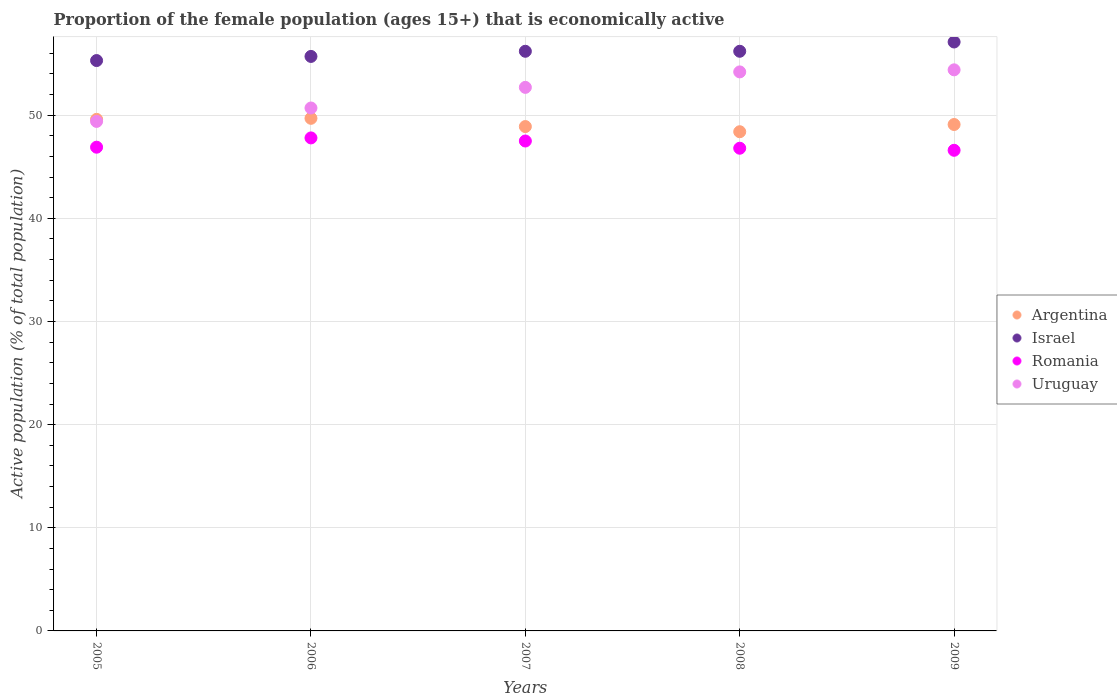Is the number of dotlines equal to the number of legend labels?
Offer a very short reply. Yes. What is the proportion of the female population that is economically active in Argentina in 2009?
Your answer should be compact. 49.1. Across all years, what is the maximum proportion of the female population that is economically active in Argentina?
Your answer should be very brief. 49.7. Across all years, what is the minimum proportion of the female population that is economically active in Romania?
Keep it short and to the point. 46.6. In which year was the proportion of the female population that is economically active in Romania maximum?
Your answer should be very brief. 2006. What is the total proportion of the female population that is economically active in Argentina in the graph?
Provide a short and direct response. 245.7. What is the difference between the proportion of the female population that is economically active in Uruguay in 2005 and that in 2007?
Provide a succinct answer. -3.3. What is the difference between the proportion of the female population that is economically active in Romania in 2007 and the proportion of the female population that is economically active in Argentina in 2008?
Your answer should be compact. -0.9. What is the average proportion of the female population that is economically active in Uruguay per year?
Offer a terse response. 52.28. In the year 2005, what is the difference between the proportion of the female population that is economically active in Israel and proportion of the female population that is economically active in Romania?
Provide a short and direct response. 8.4. In how many years, is the proportion of the female population that is economically active in Argentina greater than 38 %?
Offer a very short reply. 5. What is the ratio of the proportion of the female population that is economically active in Uruguay in 2006 to that in 2007?
Your response must be concise. 0.96. Is the proportion of the female population that is economically active in Uruguay in 2005 less than that in 2008?
Ensure brevity in your answer.  Yes. Is the difference between the proportion of the female population that is economically active in Israel in 2006 and 2008 greater than the difference between the proportion of the female population that is economically active in Romania in 2006 and 2008?
Provide a succinct answer. No. What is the difference between the highest and the second highest proportion of the female population that is economically active in Uruguay?
Keep it short and to the point. 0.2. What is the difference between the highest and the lowest proportion of the female population that is economically active in Israel?
Provide a succinct answer. 1.8. In how many years, is the proportion of the female population that is economically active in Uruguay greater than the average proportion of the female population that is economically active in Uruguay taken over all years?
Offer a very short reply. 3. Is it the case that in every year, the sum of the proportion of the female population that is economically active in Argentina and proportion of the female population that is economically active in Uruguay  is greater than the sum of proportion of the female population that is economically active in Romania and proportion of the female population that is economically active in Israel?
Ensure brevity in your answer.  Yes. Does the proportion of the female population that is economically active in Uruguay monotonically increase over the years?
Provide a short and direct response. Yes. Where does the legend appear in the graph?
Provide a succinct answer. Center right. What is the title of the graph?
Provide a short and direct response. Proportion of the female population (ages 15+) that is economically active. Does "Bahrain" appear as one of the legend labels in the graph?
Offer a very short reply. No. What is the label or title of the Y-axis?
Your answer should be compact. Active population (% of total population). What is the Active population (% of total population) of Argentina in 2005?
Keep it short and to the point. 49.6. What is the Active population (% of total population) of Israel in 2005?
Your answer should be compact. 55.3. What is the Active population (% of total population) in Romania in 2005?
Your answer should be very brief. 46.9. What is the Active population (% of total population) in Uruguay in 2005?
Ensure brevity in your answer.  49.4. What is the Active population (% of total population) in Argentina in 2006?
Make the answer very short. 49.7. What is the Active population (% of total population) of Israel in 2006?
Offer a very short reply. 55.7. What is the Active population (% of total population) in Romania in 2006?
Offer a terse response. 47.8. What is the Active population (% of total population) of Uruguay in 2006?
Your response must be concise. 50.7. What is the Active population (% of total population) of Argentina in 2007?
Your answer should be compact. 48.9. What is the Active population (% of total population) of Israel in 2007?
Keep it short and to the point. 56.2. What is the Active population (% of total population) in Romania in 2007?
Offer a very short reply. 47.5. What is the Active population (% of total population) of Uruguay in 2007?
Your answer should be very brief. 52.7. What is the Active population (% of total population) in Argentina in 2008?
Provide a short and direct response. 48.4. What is the Active population (% of total population) in Israel in 2008?
Your answer should be compact. 56.2. What is the Active population (% of total population) of Romania in 2008?
Provide a succinct answer. 46.8. What is the Active population (% of total population) in Uruguay in 2008?
Your response must be concise. 54.2. What is the Active population (% of total population) in Argentina in 2009?
Provide a succinct answer. 49.1. What is the Active population (% of total population) in Israel in 2009?
Your answer should be compact. 57.1. What is the Active population (% of total population) in Romania in 2009?
Keep it short and to the point. 46.6. What is the Active population (% of total population) in Uruguay in 2009?
Keep it short and to the point. 54.4. Across all years, what is the maximum Active population (% of total population) of Argentina?
Provide a short and direct response. 49.7. Across all years, what is the maximum Active population (% of total population) in Israel?
Your response must be concise. 57.1. Across all years, what is the maximum Active population (% of total population) of Romania?
Your answer should be compact. 47.8. Across all years, what is the maximum Active population (% of total population) of Uruguay?
Ensure brevity in your answer.  54.4. Across all years, what is the minimum Active population (% of total population) of Argentina?
Offer a terse response. 48.4. Across all years, what is the minimum Active population (% of total population) in Israel?
Make the answer very short. 55.3. Across all years, what is the minimum Active population (% of total population) of Romania?
Ensure brevity in your answer.  46.6. Across all years, what is the minimum Active population (% of total population) in Uruguay?
Offer a very short reply. 49.4. What is the total Active population (% of total population) in Argentina in the graph?
Provide a succinct answer. 245.7. What is the total Active population (% of total population) in Israel in the graph?
Ensure brevity in your answer.  280.5. What is the total Active population (% of total population) in Romania in the graph?
Keep it short and to the point. 235.6. What is the total Active population (% of total population) of Uruguay in the graph?
Provide a short and direct response. 261.4. What is the difference between the Active population (% of total population) of Argentina in 2005 and that in 2006?
Your answer should be compact. -0.1. What is the difference between the Active population (% of total population) in Israel in 2005 and that in 2006?
Make the answer very short. -0.4. What is the difference between the Active population (% of total population) of Romania in 2005 and that in 2006?
Provide a succinct answer. -0.9. What is the difference between the Active population (% of total population) in Romania in 2005 and that in 2007?
Your answer should be very brief. -0.6. What is the difference between the Active population (% of total population) of Uruguay in 2005 and that in 2007?
Your answer should be very brief. -3.3. What is the difference between the Active population (% of total population) in Argentina in 2005 and that in 2008?
Your answer should be very brief. 1.2. What is the difference between the Active population (% of total population) in Israel in 2005 and that in 2008?
Offer a very short reply. -0.9. What is the difference between the Active population (% of total population) in Romania in 2005 and that in 2008?
Provide a short and direct response. 0.1. What is the difference between the Active population (% of total population) in Argentina in 2005 and that in 2009?
Offer a terse response. 0.5. What is the difference between the Active population (% of total population) of Israel in 2005 and that in 2009?
Your answer should be very brief. -1.8. What is the difference between the Active population (% of total population) in Romania in 2005 and that in 2009?
Offer a very short reply. 0.3. What is the difference between the Active population (% of total population) of Uruguay in 2005 and that in 2009?
Make the answer very short. -5. What is the difference between the Active population (% of total population) of Argentina in 2006 and that in 2008?
Provide a succinct answer. 1.3. What is the difference between the Active population (% of total population) in Israel in 2006 and that in 2008?
Give a very brief answer. -0.5. What is the difference between the Active population (% of total population) of Romania in 2006 and that in 2008?
Offer a very short reply. 1. What is the difference between the Active population (% of total population) of Argentina in 2006 and that in 2009?
Provide a succinct answer. 0.6. What is the difference between the Active population (% of total population) in Romania in 2006 and that in 2009?
Provide a short and direct response. 1.2. What is the difference between the Active population (% of total population) in Israel in 2007 and that in 2008?
Ensure brevity in your answer.  0. What is the difference between the Active population (% of total population) of Romania in 2007 and that in 2008?
Provide a short and direct response. 0.7. What is the difference between the Active population (% of total population) of Argentina in 2007 and that in 2009?
Make the answer very short. -0.2. What is the difference between the Active population (% of total population) in Argentina in 2008 and that in 2009?
Your answer should be very brief. -0.7. What is the difference between the Active population (% of total population) in Uruguay in 2008 and that in 2009?
Your answer should be compact. -0.2. What is the difference between the Active population (% of total population) in Argentina in 2005 and the Active population (% of total population) in Israel in 2006?
Offer a very short reply. -6.1. What is the difference between the Active population (% of total population) in Argentina in 2005 and the Active population (% of total population) in Romania in 2006?
Provide a short and direct response. 1.8. What is the difference between the Active population (% of total population) in Argentina in 2005 and the Active population (% of total population) in Uruguay in 2006?
Give a very brief answer. -1.1. What is the difference between the Active population (% of total population) in Israel in 2005 and the Active population (% of total population) in Uruguay in 2006?
Provide a succinct answer. 4.6. What is the difference between the Active population (% of total population) of Romania in 2005 and the Active population (% of total population) of Uruguay in 2006?
Provide a short and direct response. -3.8. What is the difference between the Active population (% of total population) of Argentina in 2005 and the Active population (% of total population) of Uruguay in 2007?
Offer a terse response. -3.1. What is the difference between the Active population (% of total population) of Israel in 2005 and the Active population (% of total population) of Romania in 2007?
Give a very brief answer. 7.8. What is the difference between the Active population (% of total population) of Israel in 2005 and the Active population (% of total population) of Uruguay in 2007?
Your answer should be compact. 2.6. What is the difference between the Active population (% of total population) of Romania in 2005 and the Active population (% of total population) of Uruguay in 2007?
Provide a short and direct response. -5.8. What is the difference between the Active population (% of total population) of Argentina in 2005 and the Active population (% of total population) of Uruguay in 2008?
Give a very brief answer. -4.6. What is the difference between the Active population (% of total population) in Israel in 2005 and the Active population (% of total population) in Uruguay in 2008?
Keep it short and to the point. 1.1. What is the difference between the Active population (% of total population) in Romania in 2005 and the Active population (% of total population) in Uruguay in 2008?
Provide a succinct answer. -7.3. What is the difference between the Active population (% of total population) of Argentina in 2005 and the Active population (% of total population) of Israel in 2009?
Provide a succinct answer. -7.5. What is the difference between the Active population (% of total population) of Argentina in 2005 and the Active population (% of total population) of Uruguay in 2009?
Your answer should be compact. -4.8. What is the difference between the Active population (% of total population) in Israel in 2005 and the Active population (% of total population) in Uruguay in 2009?
Offer a terse response. 0.9. What is the difference between the Active population (% of total population) of Romania in 2005 and the Active population (% of total population) of Uruguay in 2009?
Your answer should be compact. -7.5. What is the difference between the Active population (% of total population) in Argentina in 2006 and the Active population (% of total population) in Romania in 2007?
Make the answer very short. 2.2. What is the difference between the Active population (% of total population) in Argentina in 2006 and the Active population (% of total population) in Uruguay in 2007?
Provide a short and direct response. -3. What is the difference between the Active population (% of total population) in Israel in 2006 and the Active population (% of total population) in Romania in 2007?
Your response must be concise. 8.2. What is the difference between the Active population (% of total population) in Argentina in 2006 and the Active population (% of total population) in Israel in 2008?
Make the answer very short. -6.5. What is the difference between the Active population (% of total population) in Argentina in 2006 and the Active population (% of total population) in Romania in 2008?
Provide a succinct answer. 2.9. What is the difference between the Active population (% of total population) in Israel in 2006 and the Active population (% of total population) in Romania in 2008?
Keep it short and to the point. 8.9. What is the difference between the Active population (% of total population) of Israel in 2006 and the Active population (% of total population) of Uruguay in 2008?
Keep it short and to the point. 1.5. What is the difference between the Active population (% of total population) in Argentina in 2006 and the Active population (% of total population) in Romania in 2009?
Keep it short and to the point. 3.1. What is the difference between the Active population (% of total population) in Romania in 2006 and the Active population (% of total population) in Uruguay in 2009?
Provide a short and direct response. -6.6. What is the difference between the Active population (% of total population) of Argentina in 2007 and the Active population (% of total population) of Romania in 2008?
Provide a succinct answer. 2.1. What is the difference between the Active population (% of total population) in Israel in 2007 and the Active population (% of total population) in Uruguay in 2008?
Offer a very short reply. 2. What is the difference between the Active population (% of total population) in Romania in 2007 and the Active population (% of total population) in Uruguay in 2008?
Offer a very short reply. -6.7. What is the difference between the Active population (% of total population) of Argentina in 2007 and the Active population (% of total population) of Romania in 2009?
Your response must be concise. 2.3. What is the difference between the Active population (% of total population) of Argentina in 2007 and the Active population (% of total population) of Uruguay in 2009?
Make the answer very short. -5.5. What is the difference between the Active population (% of total population) in Israel in 2007 and the Active population (% of total population) in Romania in 2009?
Your answer should be compact. 9.6. What is the difference between the Active population (% of total population) in Israel in 2007 and the Active population (% of total population) in Uruguay in 2009?
Your answer should be very brief. 1.8. What is the difference between the Active population (% of total population) in Romania in 2007 and the Active population (% of total population) in Uruguay in 2009?
Your answer should be very brief. -6.9. What is the difference between the Active population (% of total population) in Argentina in 2008 and the Active population (% of total population) in Uruguay in 2009?
Keep it short and to the point. -6. What is the difference between the Active population (% of total population) in Israel in 2008 and the Active population (% of total population) in Romania in 2009?
Provide a short and direct response. 9.6. What is the difference between the Active population (% of total population) of Israel in 2008 and the Active population (% of total population) of Uruguay in 2009?
Keep it short and to the point. 1.8. What is the average Active population (% of total population) of Argentina per year?
Provide a succinct answer. 49.14. What is the average Active population (% of total population) in Israel per year?
Ensure brevity in your answer.  56.1. What is the average Active population (% of total population) of Romania per year?
Offer a very short reply. 47.12. What is the average Active population (% of total population) in Uruguay per year?
Offer a very short reply. 52.28. In the year 2005, what is the difference between the Active population (% of total population) in Israel and Active population (% of total population) in Romania?
Your answer should be compact. 8.4. In the year 2005, what is the difference between the Active population (% of total population) in Israel and Active population (% of total population) in Uruguay?
Give a very brief answer. 5.9. In the year 2005, what is the difference between the Active population (% of total population) in Romania and Active population (% of total population) in Uruguay?
Offer a very short reply. -2.5. In the year 2006, what is the difference between the Active population (% of total population) of Argentina and Active population (% of total population) of Israel?
Your answer should be compact. -6. In the year 2006, what is the difference between the Active population (% of total population) in Argentina and Active population (% of total population) in Uruguay?
Your response must be concise. -1. In the year 2006, what is the difference between the Active population (% of total population) of Israel and Active population (% of total population) of Romania?
Give a very brief answer. 7.9. In the year 2006, what is the difference between the Active population (% of total population) of Israel and Active population (% of total population) of Uruguay?
Offer a terse response. 5. In the year 2006, what is the difference between the Active population (% of total population) of Romania and Active population (% of total population) of Uruguay?
Give a very brief answer. -2.9. In the year 2007, what is the difference between the Active population (% of total population) in Argentina and Active population (% of total population) in Israel?
Your answer should be very brief. -7.3. In the year 2007, what is the difference between the Active population (% of total population) of Israel and Active population (% of total population) of Romania?
Give a very brief answer. 8.7. In the year 2007, what is the difference between the Active population (% of total population) in Israel and Active population (% of total population) in Uruguay?
Provide a short and direct response. 3.5. In the year 2008, what is the difference between the Active population (% of total population) of Argentina and Active population (% of total population) of Israel?
Make the answer very short. -7.8. In the year 2008, what is the difference between the Active population (% of total population) of Argentina and Active population (% of total population) of Uruguay?
Offer a very short reply. -5.8. In the year 2008, what is the difference between the Active population (% of total population) of Romania and Active population (% of total population) of Uruguay?
Offer a terse response. -7.4. In the year 2009, what is the difference between the Active population (% of total population) in Argentina and Active population (% of total population) in Uruguay?
Provide a succinct answer. -5.3. In the year 2009, what is the difference between the Active population (% of total population) of Israel and Active population (% of total population) of Romania?
Keep it short and to the point. 10.5. In the year 2009, what is the difference between the Active population (% of total population) of Romania and Active population (% of total population) of Uruguay?
Your answer should be compact. -7.8. What is the ratio of the Active population (% of total population) of Argentina in 2005 to that in 2006?
Provide a succinct answer. 1. What is the ratio of the Active population (% of total population) of Romania in 2005 to that in 2006?
Provide a succinct answer. 0.98. What is the ratio of the Active population (% of total population) in Uruguay in 2005 to that in 2006?
Your answer should be very brief. 0.97. What is the ratio of the Active population (% of total population) in Argentina in 2005 to that in 2007?
Keep it short and to the point. 1.01. What is the ratio of the Active population (% of total population) in Israel in 2005 to that in 2007?
Offer a terse response. 0.98. What is the ratio of the Active population (% of total population) in Romania in 2005 to that in 2007?
Ensure brevity in your answer.  0.99. What is the ratio of the Active population (% of total population) of Uruguay in 2005 to that in 2007?
Provide a succinct answer. 0.94. What is the ratio of the Active population (% of total population) in Argentina in 2005 to that in 2008?
Offer a terse response. 1.02. What is the ratio of the Active population (% of total population) in Israel in 2005 to that in 2008?
Ensure brevity in your answer.  0.98. What is the ratio of the Active population (% of total population) in Uruguay in 2005 to that in 2008?
Your answer should be very brief. 0.91. What is the ratio of the Active population (% of total population) in Argentina in 2005 to that in 2009?
Provide a succinct answer. 1.01. What is the ratio of the Active population (% of total population) of Israel in 2005 to that in 2009?
Offer a terse response. 0.97. What is the ratio of the Active population (% of total population) in Romania in 2005 to that in 2009?
Your response must be concise. 1.01. What is the ratio of the Active population (% of total population) of Uruguay in 2005 to that in 2009?
Provide a succinct answer. 0.91. What is the ratio of the Active population (% of total population) in Argentina in 2006 to that in 2007?
Your answer should be compact. 1.02. What is the ratio of the Active population (% of total population) of Israel in 2006 to that in 2007?
Offer a very short reply. 0.99. What is the ratio of the Active population (% of total population) in Romania in 2006 to that in 2007?
Give a very brief answer. 1.01. What is the ratio of the Active population (% of total population) in Argentina in 2006 to that in 2008?
Provide a short and direct response. 1.03. What is the ratio of the Active population (% of total population) of Romania in 2006 to that in 2008?
Offer a very short reply. 1.02. What is the ratio of the Active population (% of total population) of Uruguay in 2006 to that in 2008?
Offer a terse response. 0.94. What is the ratio of the Active population (% of total population) in Argentina in 2006 to that in 2009?
Ensure brevity in your answer.  1.01. What is the ratio of the Active population (% of total population) in Israel in 2006 to that in 2009?
Make the answer very short. 0.98. What is the ratio of the Active population (% of total population) in Romania in 2006 to that in 2009?
Your answer should be very brief. 1.03. What is the ratio of the Active population (% of total population) of Uruguay in 2006 to that in 2009?
Provide a short and direct response. 0.93. What is the ratio of the Active population (% of total population) in Argentina in 2007 to that in 2008?
Your answer should be compact. 1.01. What is the ratio of the Active population (% of total population) in Israel in 2007 to that in 2008?
Offer a very short reply. 1. What is the ratio of the Active population (% of total population) in Romania in 2007 to that in 2008?
Make the answer very short. 1.01. What is the ratio of the Active population (% of total population) in Uruguay in 2007 to that in 2008?
Offer a terse response. 0.97. What is the ratio of the Active population (% of total population) of Argentina in 2007 to that in 2009?
Make the answer very short. 1. What is the ratio of the Active population (% of total population) in Israel in 2007 to that in 2009?
Make the answer very short. 0.98. What is the ratio of the Active population (% of total population) in Romania in 2007 to that in 2009?
Offer a very short reply. 1.02. What is the ratio of the Active population (% of total population) in Uruguay in 2007 to that in 2009?
Provide a succinct answer. 0.97. What is the ratio of the Active population (% of total population) in Argentina in 2008 to that in 2009?
Your answer should be very brief. 0.99. What is the ratio of the Active population (% of total population) in Israel in 2008 to that in 2009?
Your answer should be compact. 0.98. What is the ratio of the Active population (% of total population) in Romania in 2008 to that in 2009?
Ensure brevity in your answer.  1. What is the ratio of the Active population (% of total population) in Uruguay in 2008 to that in 2009?
Offer a very short reply. 1. What is the difference between the highest and the lowest Active population (% of total population) in Argentina?
Provide a succinct answer. 1.3. What is the difference between the highest and the lowest Active population (% of total population) of Uruguay?
Ensure brevity in your answer.  5. 